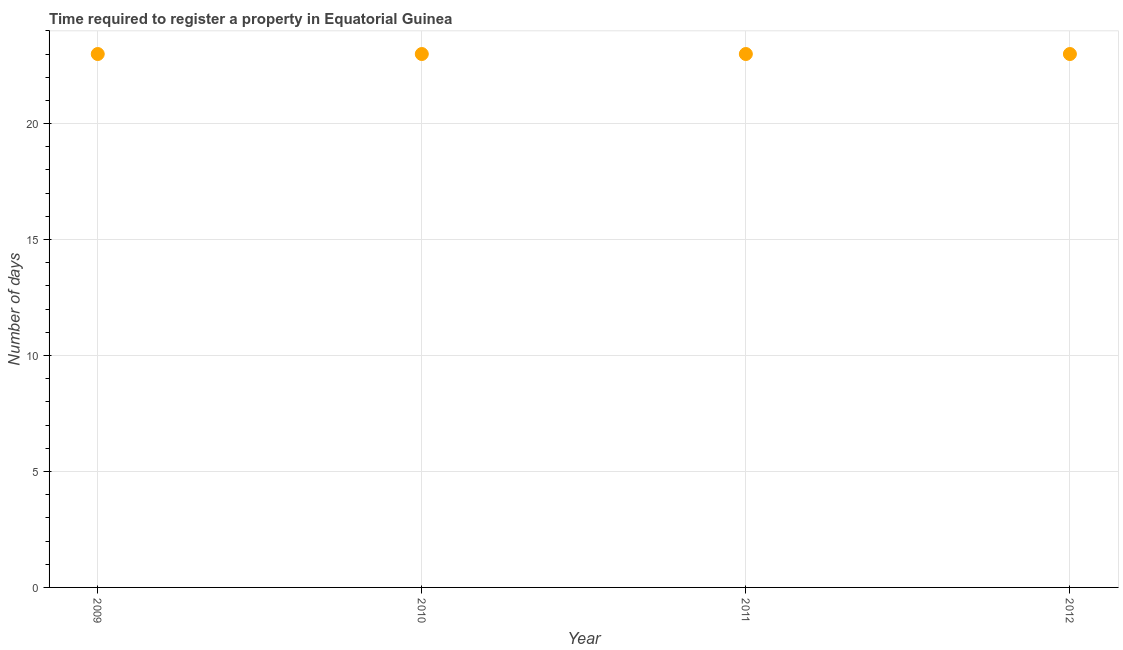What is the number of days required to register property in 2010?
Provide a succinct answer. 23. Across all years, what is the maximum number of days required to register property?
Give a very brief answer. 23. Across all years, what is the minimum number of days required to register property?
Provide a short and direct response. 23. In which year was the number of days required to register property minimum?
Offer a terse response. 2009. What is the sum of the number of days required to register property?
Give a very brief answer. 92. What is the median number of days required to register property?
Offer a very short reply. 23. Do a majority of the years between 2010 and 2012 (inclusive) have number of days required to register property greater than 7 days?
Give a very brief answer. Yes. Is the number of days required to register property in 2010 less than that in 2011?
Offer a terse response. No. Is the sum of the number of days required to register property in 2009 and 2010 greater than the maximum number of days required to register property across all years?
Offer a very short reply. Yes. In how many years, is the number of days required to register property greater than the average number of days required to register property taken over all years?
Provide a short and direct response. 0. Does the number of days required to register property monotonically increase over the years?
Your answer should be compact. No. How many dotlines are there?
Ensure brevity in your answer.  1. What is the difference between two consecutive major ticks on the Y-axis?
Offer a very short reply. 5. Are the values on the major ticks of Y-axis written in scientific E-notation?
Offer a terse response. No. Does the graph contain any zero values?
Your answer should be compact. No. Does the graph contain grids?
Provide a short and direct response. Yes. What is the title of the graph?
Your answer should be very brief. Time required to register a property in Equatorial Guinea. What is the label or title of the X-axis?
Provide a succinct answer. Year. What is the label or title of the Y-axis?
Offer a terse response. Number of days. What is the Number of days in 2009?
Your answer should be compact. 23. What is the Number of days in 2010?
Offer a very short reply. 23. What is the Number of days in 2011?
Ensure brevity in your answer.  23. What is the Number of days in 2012?
Give a very brief answer. 23. What is the difference between the Number of days in 2009 and 2010?
Keep it short and to the point. 0. What is the difference between the Number of days in 2009 and 2011?
Your response must be concise. 0. What is the difference between the Number of days in 2009 and 2012?
Your answer should be compact. 0. What is the difference between the Number of days in 2010 and 2012?
Your answer should be compact. 0. What is the difference between the Number of days in 2011 and 2012?
Your answer should be very brief. 0. What is the ratio of the Number of days in 2009 to that in 2011?
Ensure brevity in your answer.  1. What is the ratio of the Number of days in 2009 to that in 2012?
Provide a succinct answer. 1. What is the ratio of the Number of days in 2011 to that in 2012?
Ensure brevity in your answer.  1. 